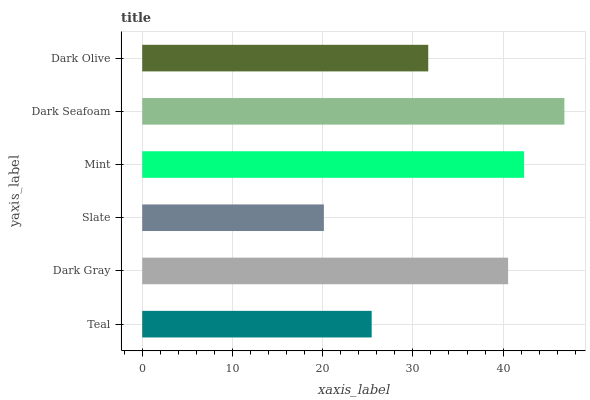Is Slate the minimum?
Answer yes or no. Yes. Is Dark Seafoam the maximum?
Answer yes or no. Yes. Is Dark Gray the minimum?
Answer yes or no. No. Is Dark Gray the maximum?
Answer yes or no. No. Is Dark Gray greater than Teal?
Answer yes or no. Yes. Is Teal less than Dark Gray?
Answer yes or no. Yes. Is Teal greater than Dark Gray?
Answer yes or no. No. Is Dark Gray less than Teal?
Answer yes or no. No. Is Dark Gray the high median?
Answer yes or no. Yes. Is Dark Olive the low median?
Answer yes or no. Yes. Is Dark Olive the high median?
Answer yes or no. No. Is Slate the low median?
Answer yes or no. No. 